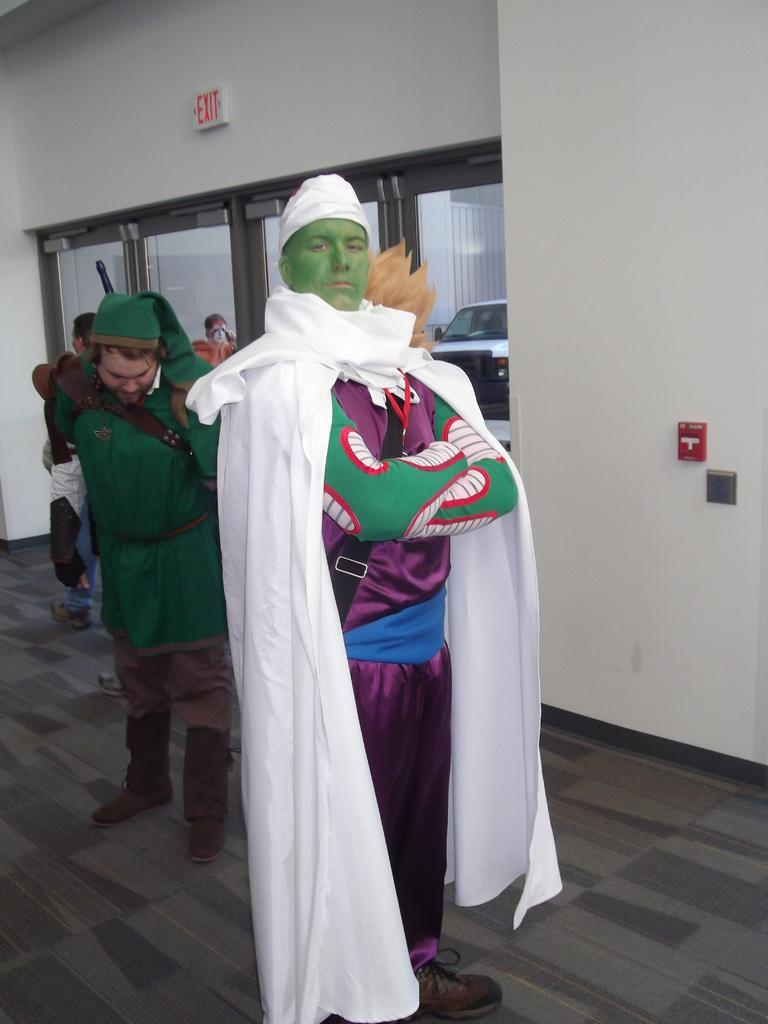What are the people in the image doing? The people in the image are standing, and they are wearing costumes. What can be seen in the background of the image? There are doors and a vehicle in the background of the image. Can you describe any signage in the image? Yes, there is an exit sign board in the image. What type of education is being offered by the company in the image? There is no reference to education or a company in the image, so it is not possible to answer that question. 